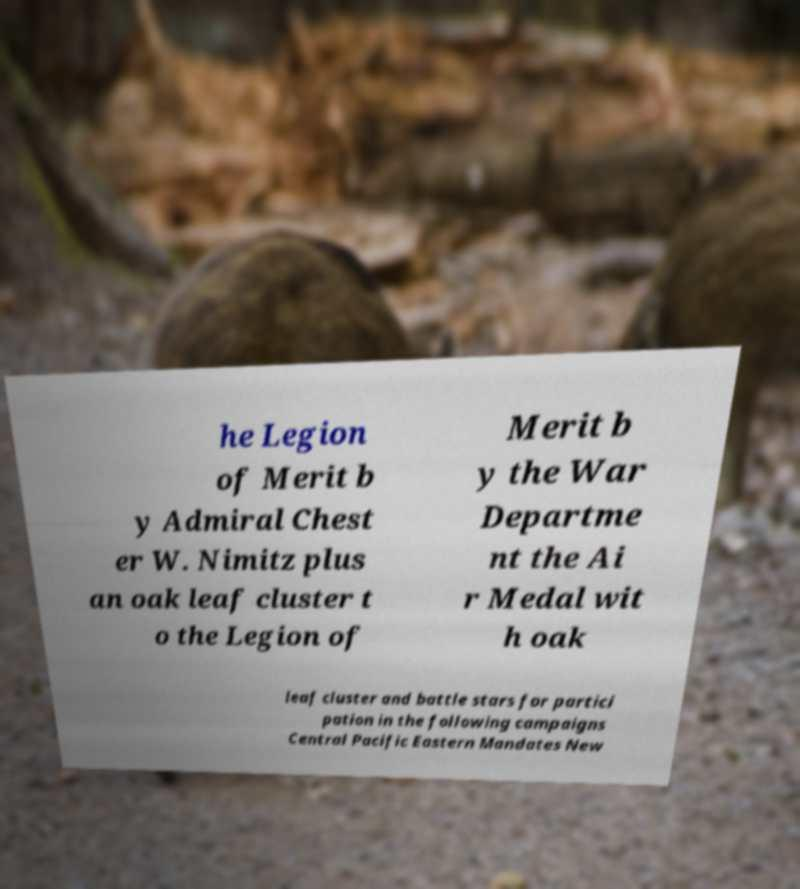Could you assist in decoding the text presented in this image and type it out clearly? he Legion of Merit b y Admiral Chest er W. Nimitz plus an oak leaf cluster t o the Legion of Merit b y the War Departme nt the Ai r Medal wit h oak leaf cluster and battle stars for partici pation in the following campaigns Central Pacific Eastern Mandates New 